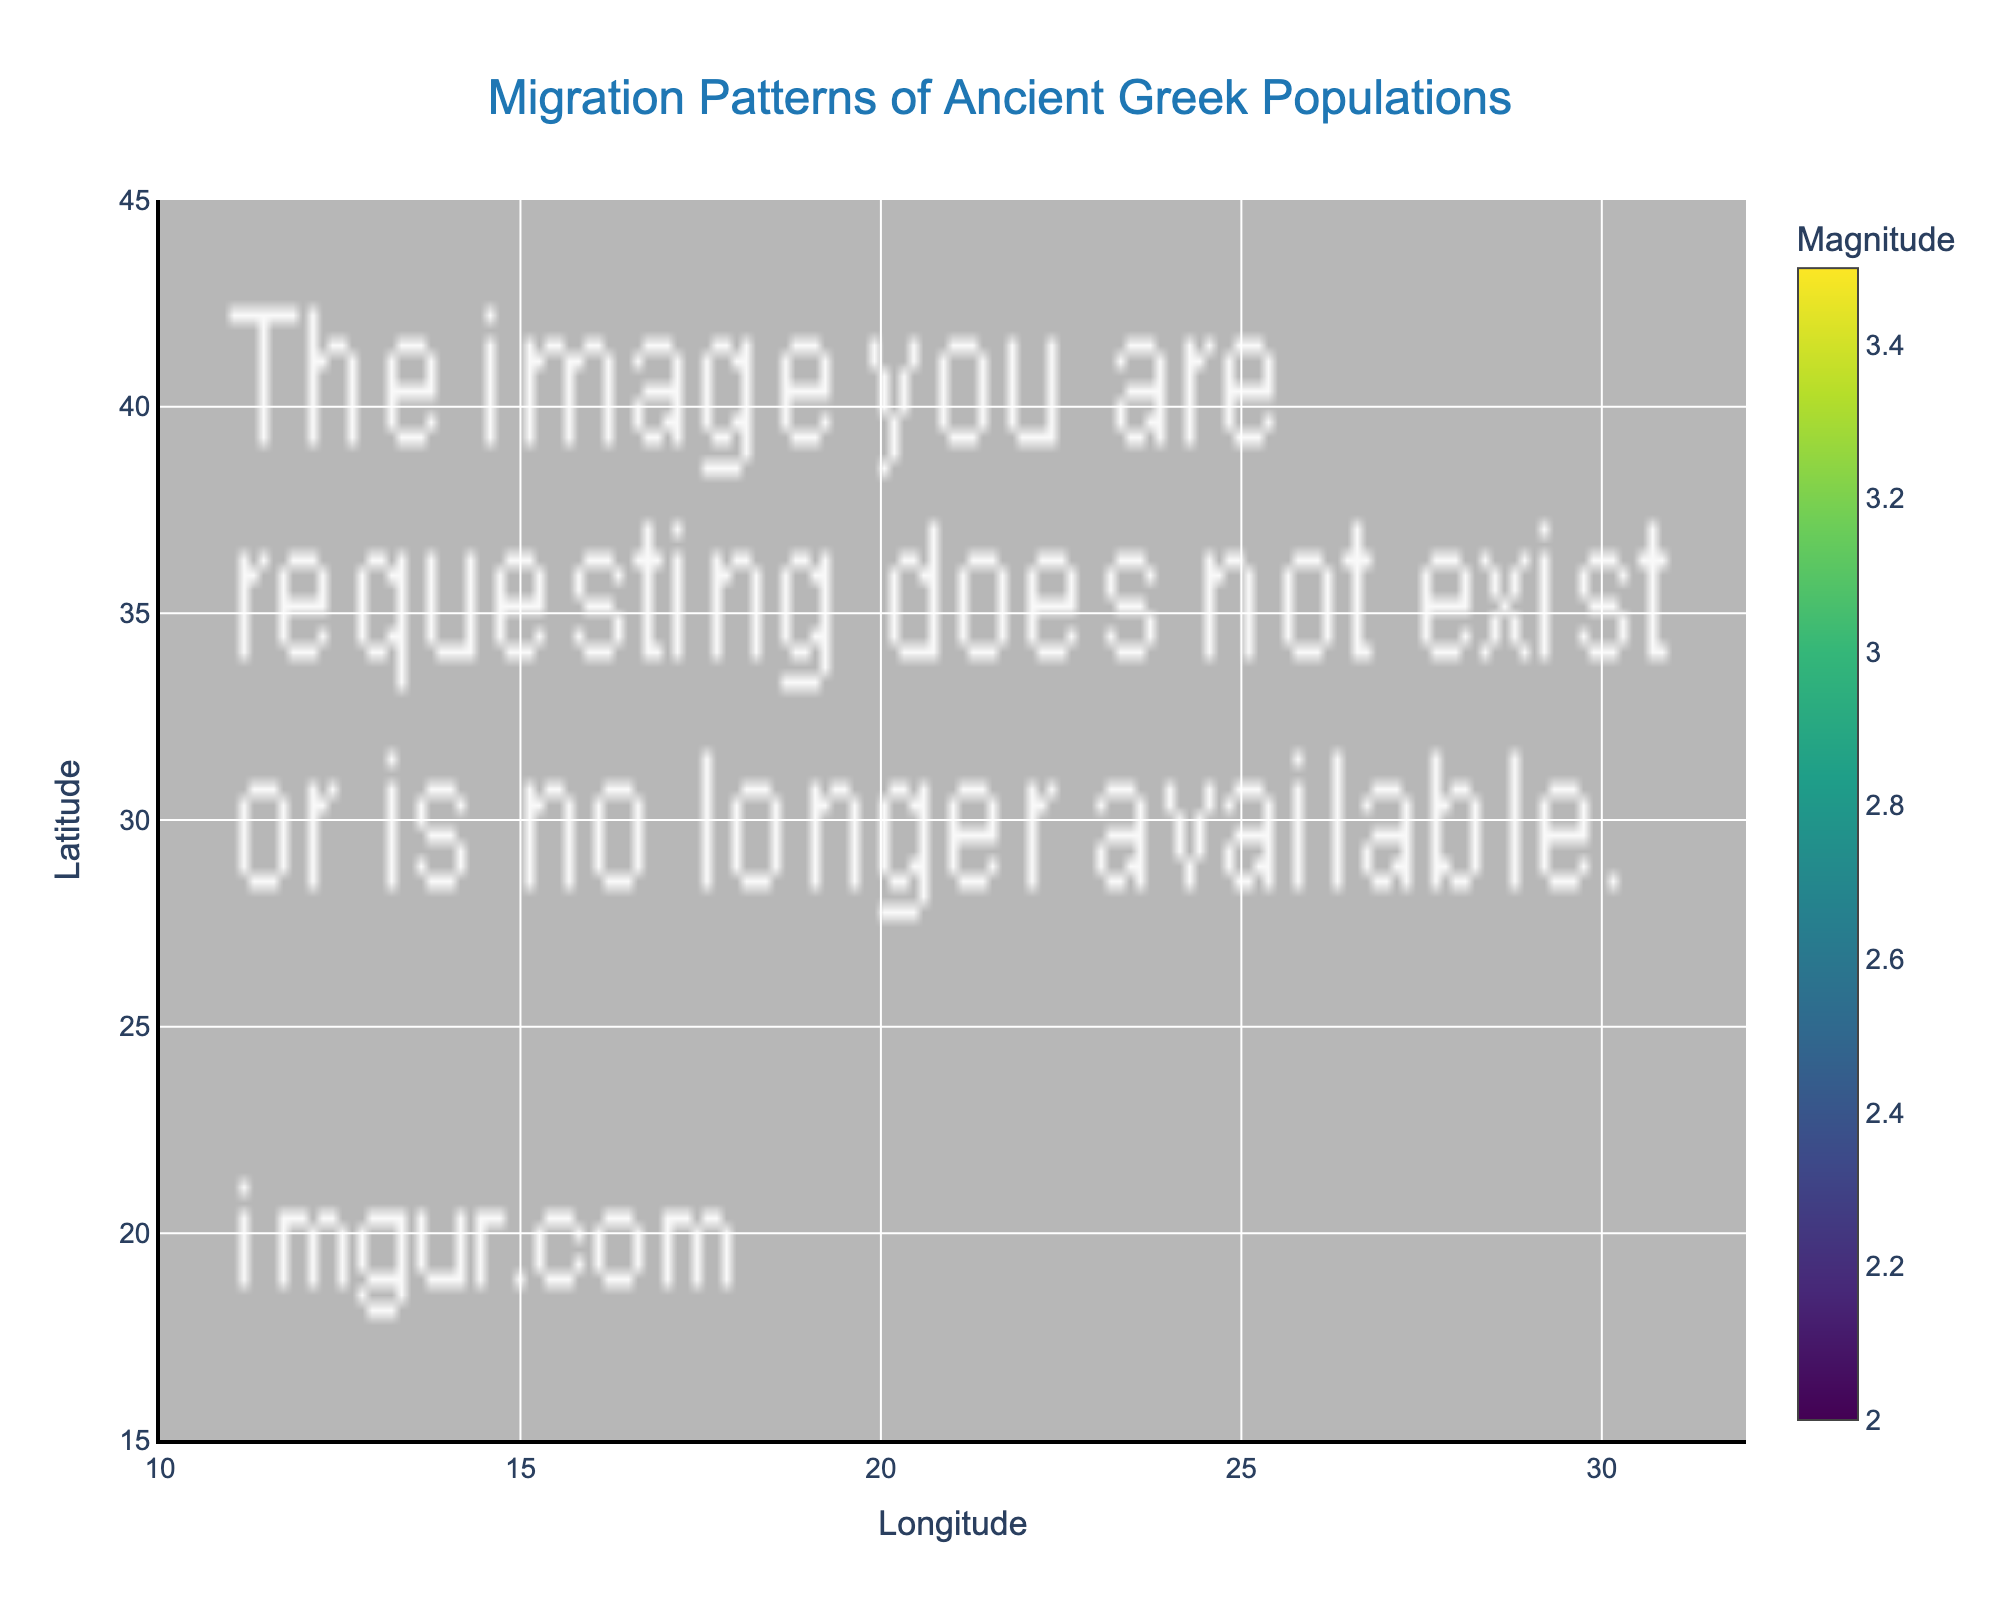What's the title of the figure? The title is written at the top of the figure in a larger font.
Answer: Migration Patterns of Ancient Greek Populations What does the color of the markers indicate? By observing the color scale legend on the right side of the figure, it is clear that the color of the markers represents the magnitude of the migration. Colors range from purple (low magnitude) to yellow (high magnitude).
Answer: Magnitude of migration Which migration has the highest magnitude and what is its value? Examine the color of the markers and refer to the color scale legend. The brightest yellow marker represents the highest magnitude, located at Heraklion with a magnitude of 3.5. The value of 3.5 is also shown in the data in the appropriate row.
Answer: Heraklion to Rhodes, 3.5 How many migration paths originate from Greece? Greece includes cities like Athens, Thessaloniki, Sparta, Patras, Heraklion, and Rhodes. Count the markers associated with these cities. There are six markers from Greek cities.
Answer: 6 Which migration shows movement towards the northeast direction? Movement towards the northeast means both 'u' and 'v' are positive. Look for a migration where u > 0 and v > 0. The data shows that Corfu to Tarentum (u=2, v=1) is northeast direction.
Answer: Corfu to Tarentum Which migration shows the largest southward movement? Southward movement implies the most negative 'v' value. By examining the table, Sparta to Syracuse has the most negative 'v' value of -3.
Answer: Sparta to Syracuse What is the longitude and latitude range used for the x-axis and y-axis? The x-axis range is specified in the code with a latitude (y) range [15, 45] and a longitude (x) range [10, 32].
Answer: Longitude: 10 to 32, Latitude: 15 to 45 Compare the magnitude of migration from Athens to Ephesus and Patras to Alexandria. Which one had the higher value? Look at the color scale and the migration markers. Athens to Ephesus has a magnitude of 3, and Patras to Alexandria also has a magnitude of 3. Both magnitudes are equal.
Answer: Both are 3 Which migration is directed towards the southwest? Movement towards the southwest means 'u' is negative and 'v' is negative. Checking the data, Athens to Ephesus (u=-2, v=-1) and Antalya to Cyrene (u=-2, v=-2) show southwest direction.
Answer: Athens to Ephesus, Antalya to Cyrene 